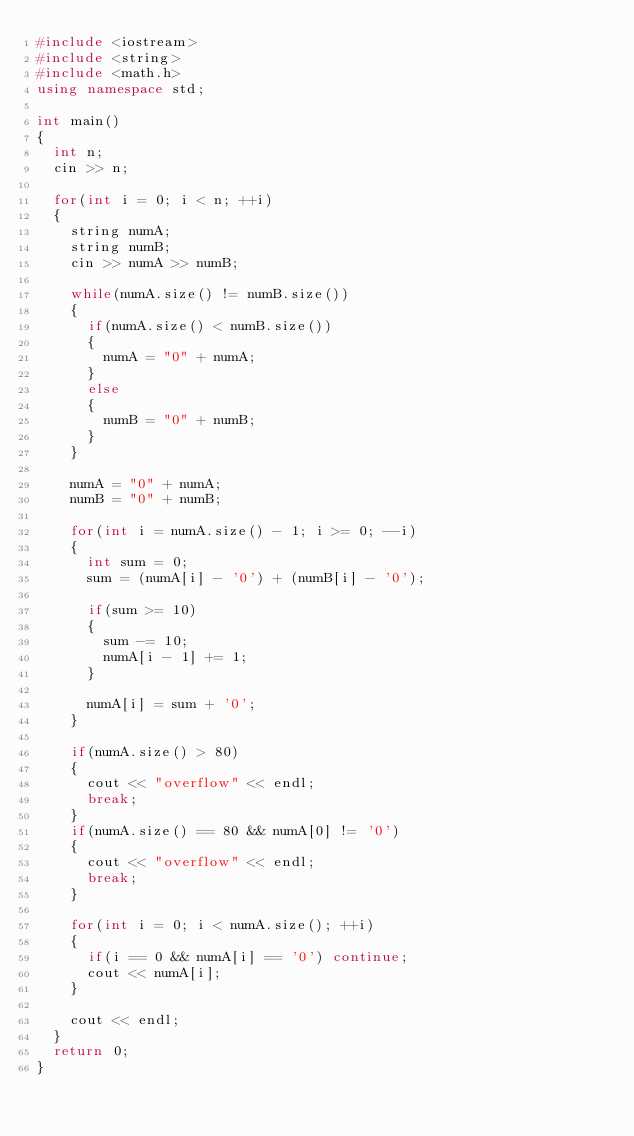Convert code to text. <code><loc_0><loc_0><loc_500><loc_500><_C++_>#include <iostream>
#include <string>
#include <math.h>
using namespace std;

int main()
{
	int n;
	cin >> n;
	
	for(int i = 0; i < n; ++i)
	{
		string numA;
		string numB;
		cin >> numA >> numB;
		
		while(numA.size() != numB.size())
		{
			if(numA.size() < numB.size())
			{
				numA = "0" + numA;
			}
			else
			{
				numB = "0" + numB;
			}
		}
		
		numA = "0" + numA;
		numB = "0" + numB;
		
		for(int i = numA.size() - 1; i >= 0; --i)
		{
			int sum = 0;
			sum = (numA[i] - '0') + (numB[i] - '0');
			
			if(sum >= 10)
			{
				sum -= 10;
				numA[i - 1] += 1;
			}
			
			numA[i] = sum + '0';
		}
		
		if(numA.size() > 80)
		{
			cout << "overflow" << endl;
			break;
		}
		if(numA.size() == 80 && numA[0] != '0')
		{
			cout << "overflow" << endl;
			break;
		}
		
		for(int i = 0; i < numA.size(); ++i)
		{
			if(i == 0 && numA[i] == '0') continue;
			cout << numA[i];
		}
		
		cout << endl;
	}
	return 0;
}</code> 